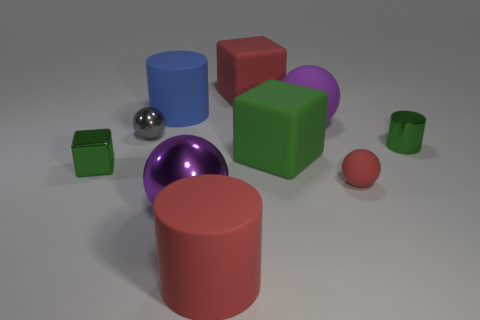Are there any other things that are made of the same material as the small red object?
Provide a short and direct response. Yes. Is there a tiny object?
Offer a terse response. Yes. The other cylinder that is made of the same material as the big red cylinder is what color?
Your answer should be compact. Blue. What color is the metal object that is behind the green thing that is behind the big rubber block in front of the red matte block?
Offer a very short reply. Gray. Does the gray shiny object have the same size as the green object on the right side of the big purple matte ball?
Offer a very short reply. Yes. How many things are either small metal things that are to the left of the red rubber sphere or blocks right of the red rubber block?
Provide a short and direct response. 3. There is a gray thing that is the same size as the red matte sphere; what is its shape?
Keep it short and to the point. Sphere. The tiny metal object that is to the right of the big purple object behind the large sphere that is to the left of the big purple rubber sphere is what shape?
Provide a succinct answer. Cylinder. Is the number of large red cubes in front of the large purple matte thing the same as the number of tiny green rubber spheres?
Your response must be concise. Yes. Is the purple metal sphere the same size as the red cylinder?
Provide a succinct answer. Yes. 